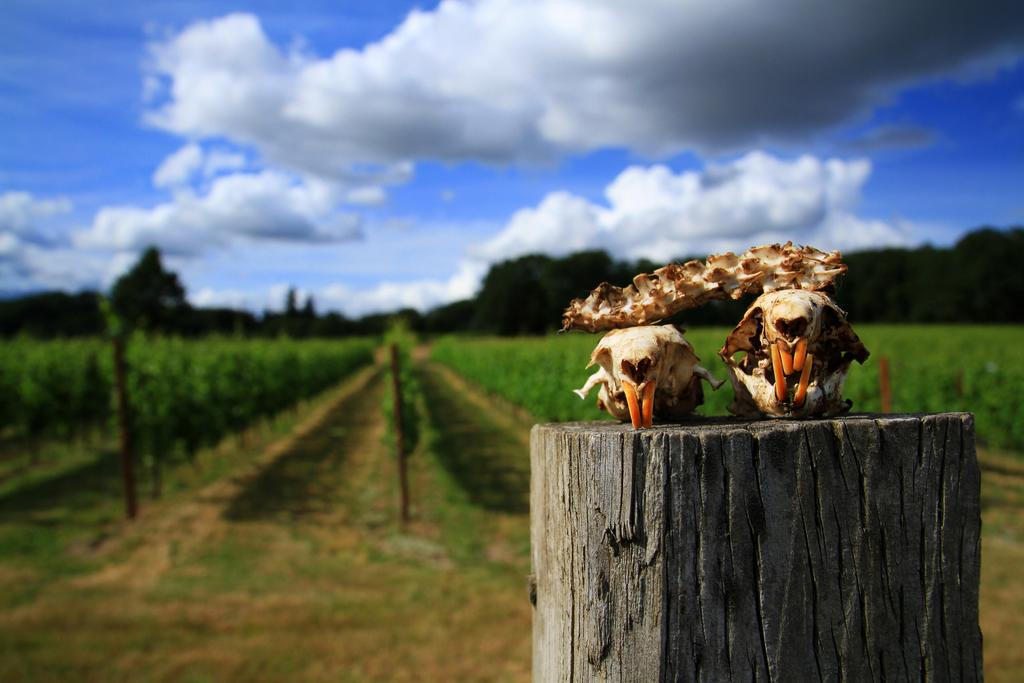What objects are placed on the wooden plank in the image? There are skulls of animals on a wooden plank in the image. What type of vegetation can be seen in the image? There is a crop and plants visible in the image. What is the weather like in the image? The sky is sunny in the image. What type of fan is being used to tell a story in the image? There is no fan or storytelling depicted in the image; it features skulls of animals, a crop, plants, and a sunny sky. 